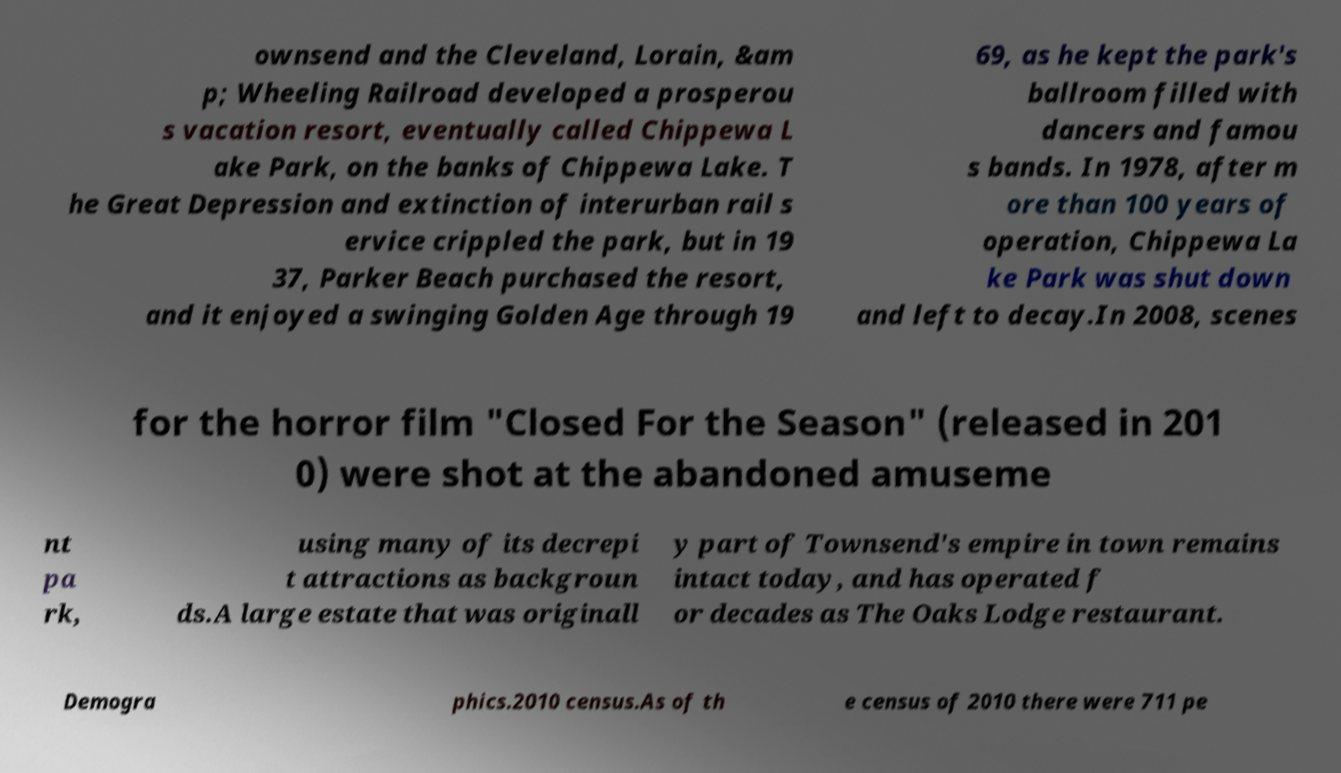Can you accurately transcribe the text from the provided image for me? ownsend and the Cleveland, Lorain, &am p; Wheeling Railroad developed a prosperou s vacation resort, eventually called Chippewa L ake Park, on the banks of Chippewa Lake. T he Great Depression and extinction of interurban rail s ervice crippled the park, but in 19 37, Parker Beach purchased the resort, and it enjoyed a swinging Golden Age through 19 69, as he kept the park's ballroom filled with dancers and famou s bands. In 1978, after m ore than 100 years of operation, Chippewa La ke Park was shut down and left to decay.In 2008, scenes for the horror film "Closed For the Season" (released in 201 0) were shot at the abandoned amuseme nt pa rk, using many of its decrepi t attractions as backgroun ds.A large estate that was originall y part of Townsend's empire in town remains intact today, and has operated f or decades as The Oaks Lodge restaurant. Demogra phics.2010 census.As of th e census of 2010 there were 711 pe 